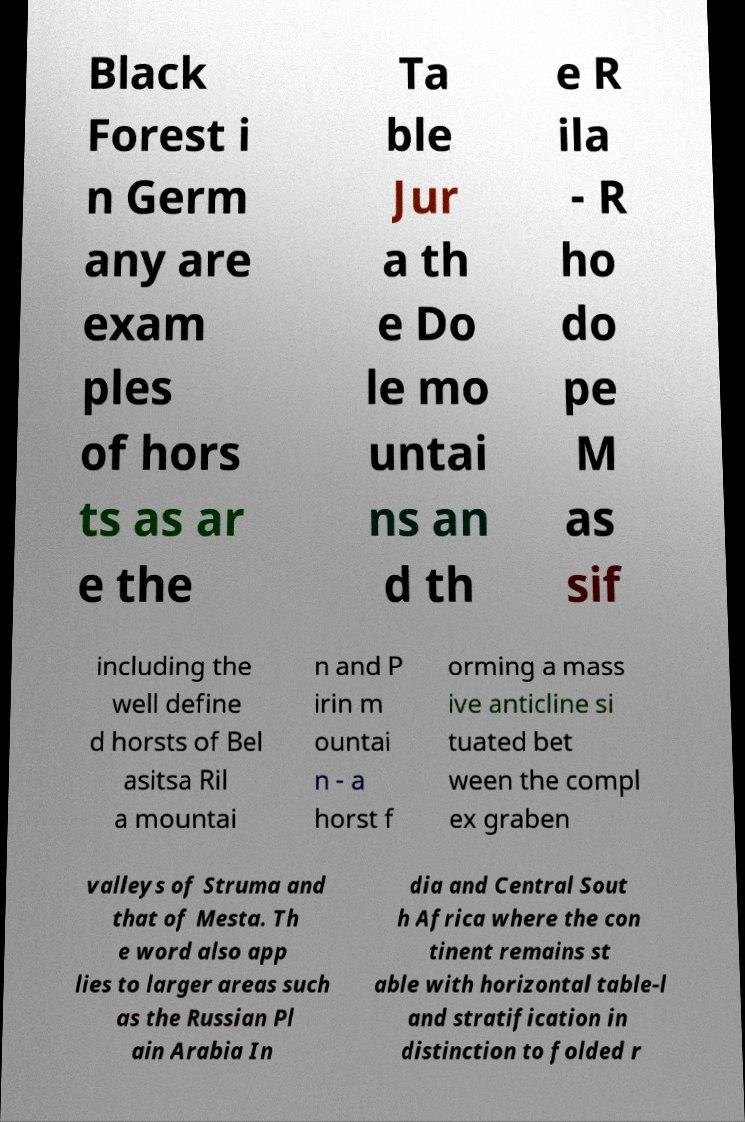There's text embedded in this image that I need extracted. Can you transcribe it verbatim? Black Forest i n Germ any are exam ples of hors ts as ar e the Ta ble Jur a th e Do le mo untai ns an d th e R ila - R ho do pe M as sif including the well define d horsts of Bel asitsa Ril a mountai n and P irin m ountai n - a horst f orming a mass ive anticline si tuated bet ween the compl ex graben valleys of Struma and that of Mesta. Th e word also app lies to larger areas such as the Russian Pl ain Arabia In dia and Central Sout h Africa where the con tinent remains st able with horizontal table-l and stratification in distinction to folded r 